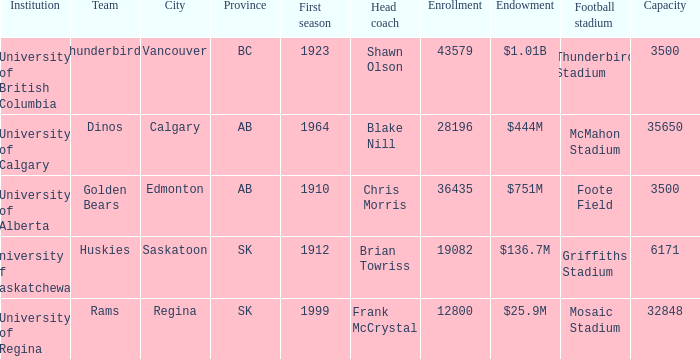What is the admission for foote field? 36435.0. 